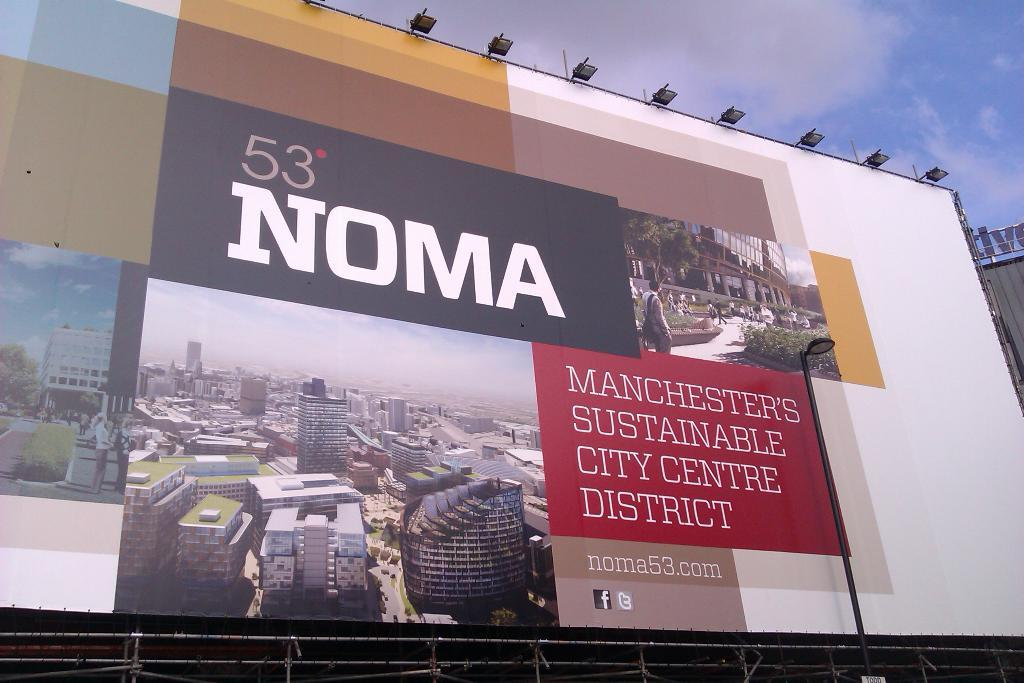<image>
Describe the image concisely. A billboard for Manchesters City Centre District has pictures of the city on it 